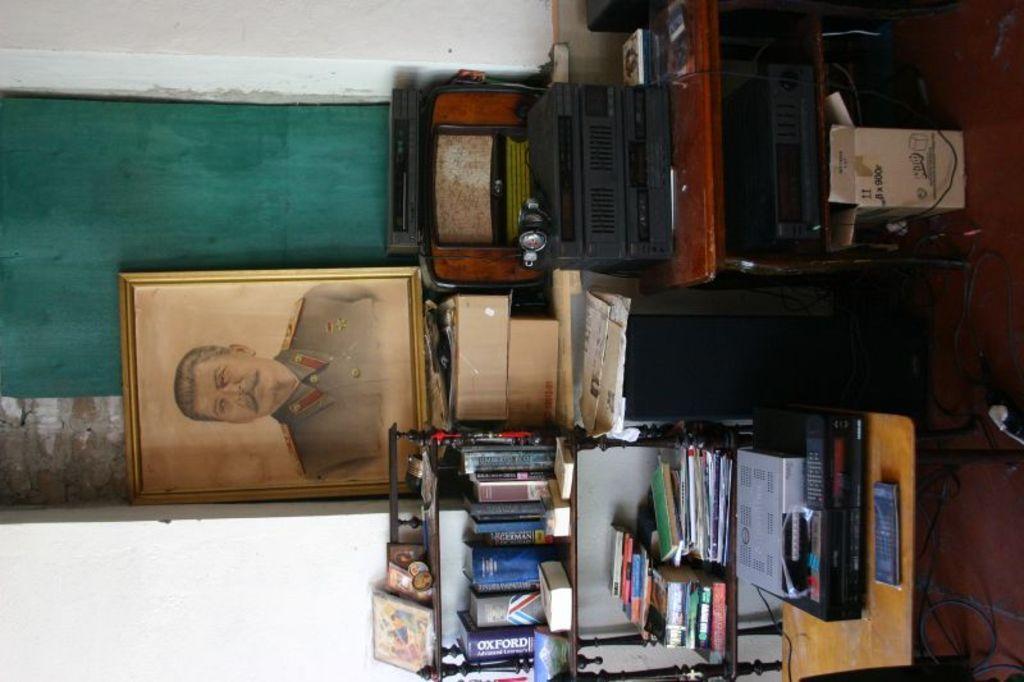Describe this image in one or two sentences. In the picture I can see a wooden table on the floor. I can see the electronic device on the table and there is a stock box on the floor on the top right side of the picture. I can see the books on the wooden shelves which is at the bottom of the picture. There is a photo frame on the wall on the left side. 